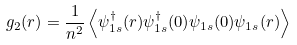<formula> <loc_0><loc_0><loc_500><loc_500>g _ { 2 } ( { r } ) = \frac { 1 } { n ^ { 2 } } \left \langle \psi ^ { \dagger } _ { 1 s } ( { r } ) \psi ^ { \dagger } _ { 1 s } ( { 0 } ) \psi _ { 1 s } ( { 0 } ) \psi _ { 1 s } ( { r } ) \right \rangle</formula> 